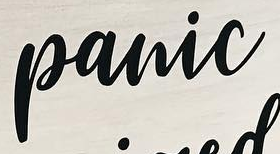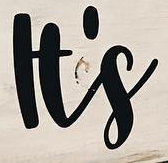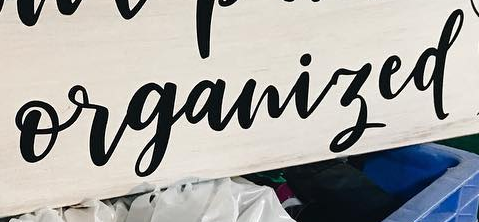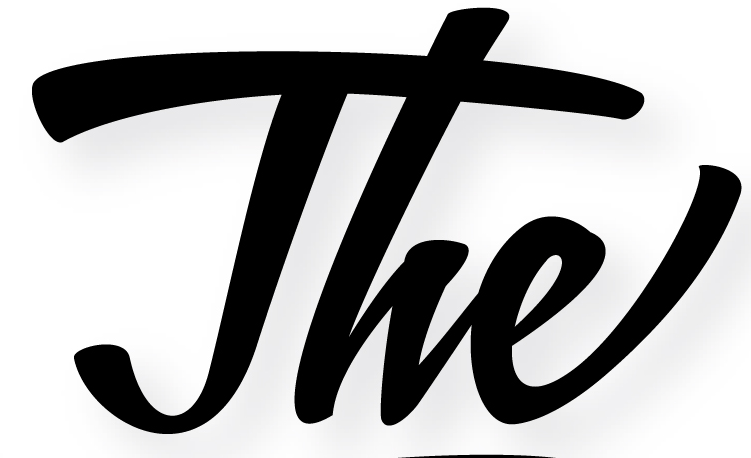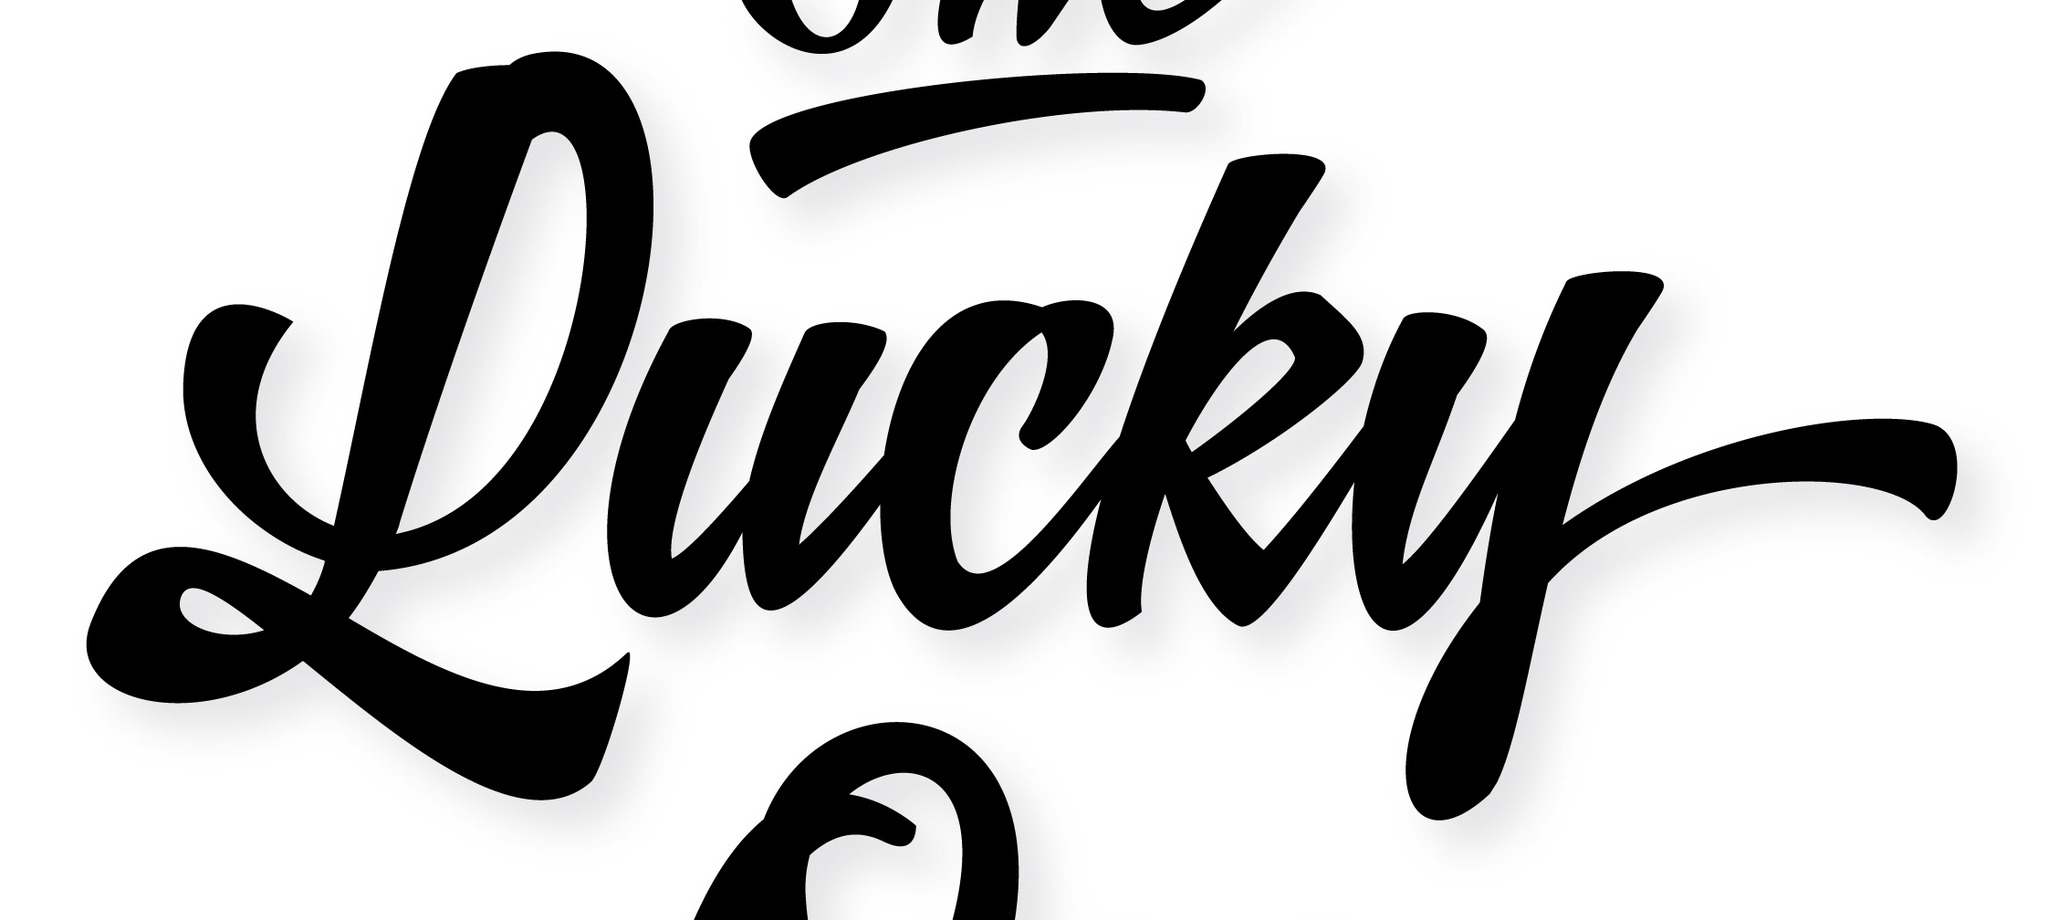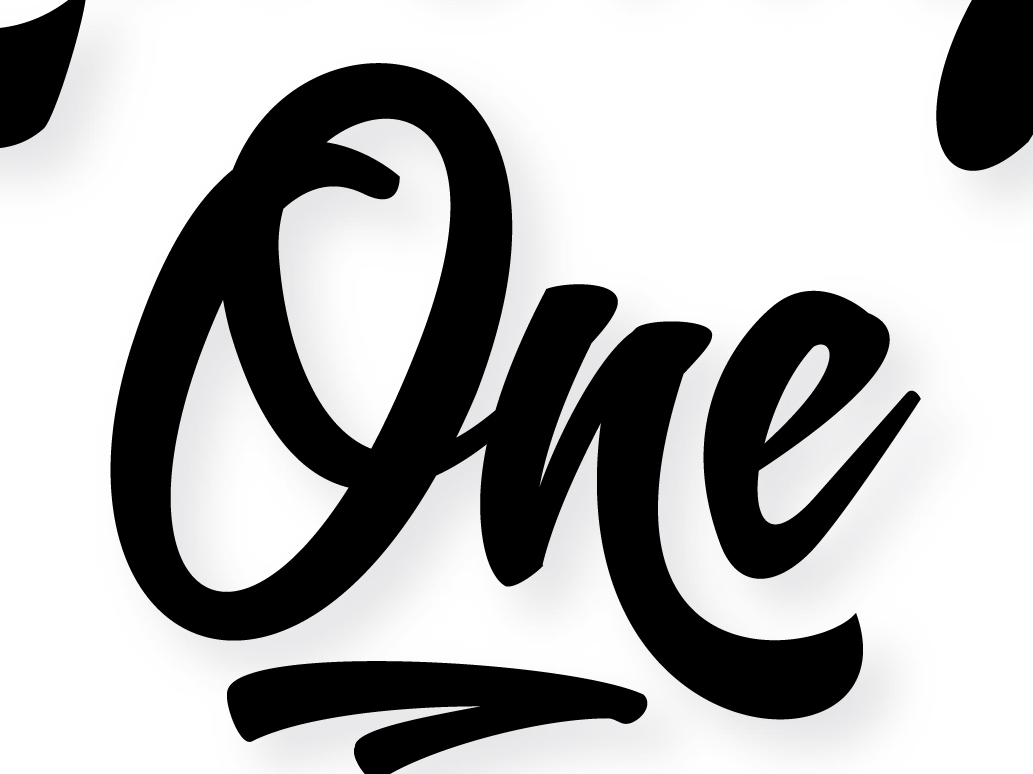Read the text content from these images in order, separated by a semicolon. panic; It's; organized; The; Lucky; One 